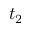Convert formula to latex. <formula><loc_0><loc_0><loc_500><loc_500>t _ { 2 }</formula> 